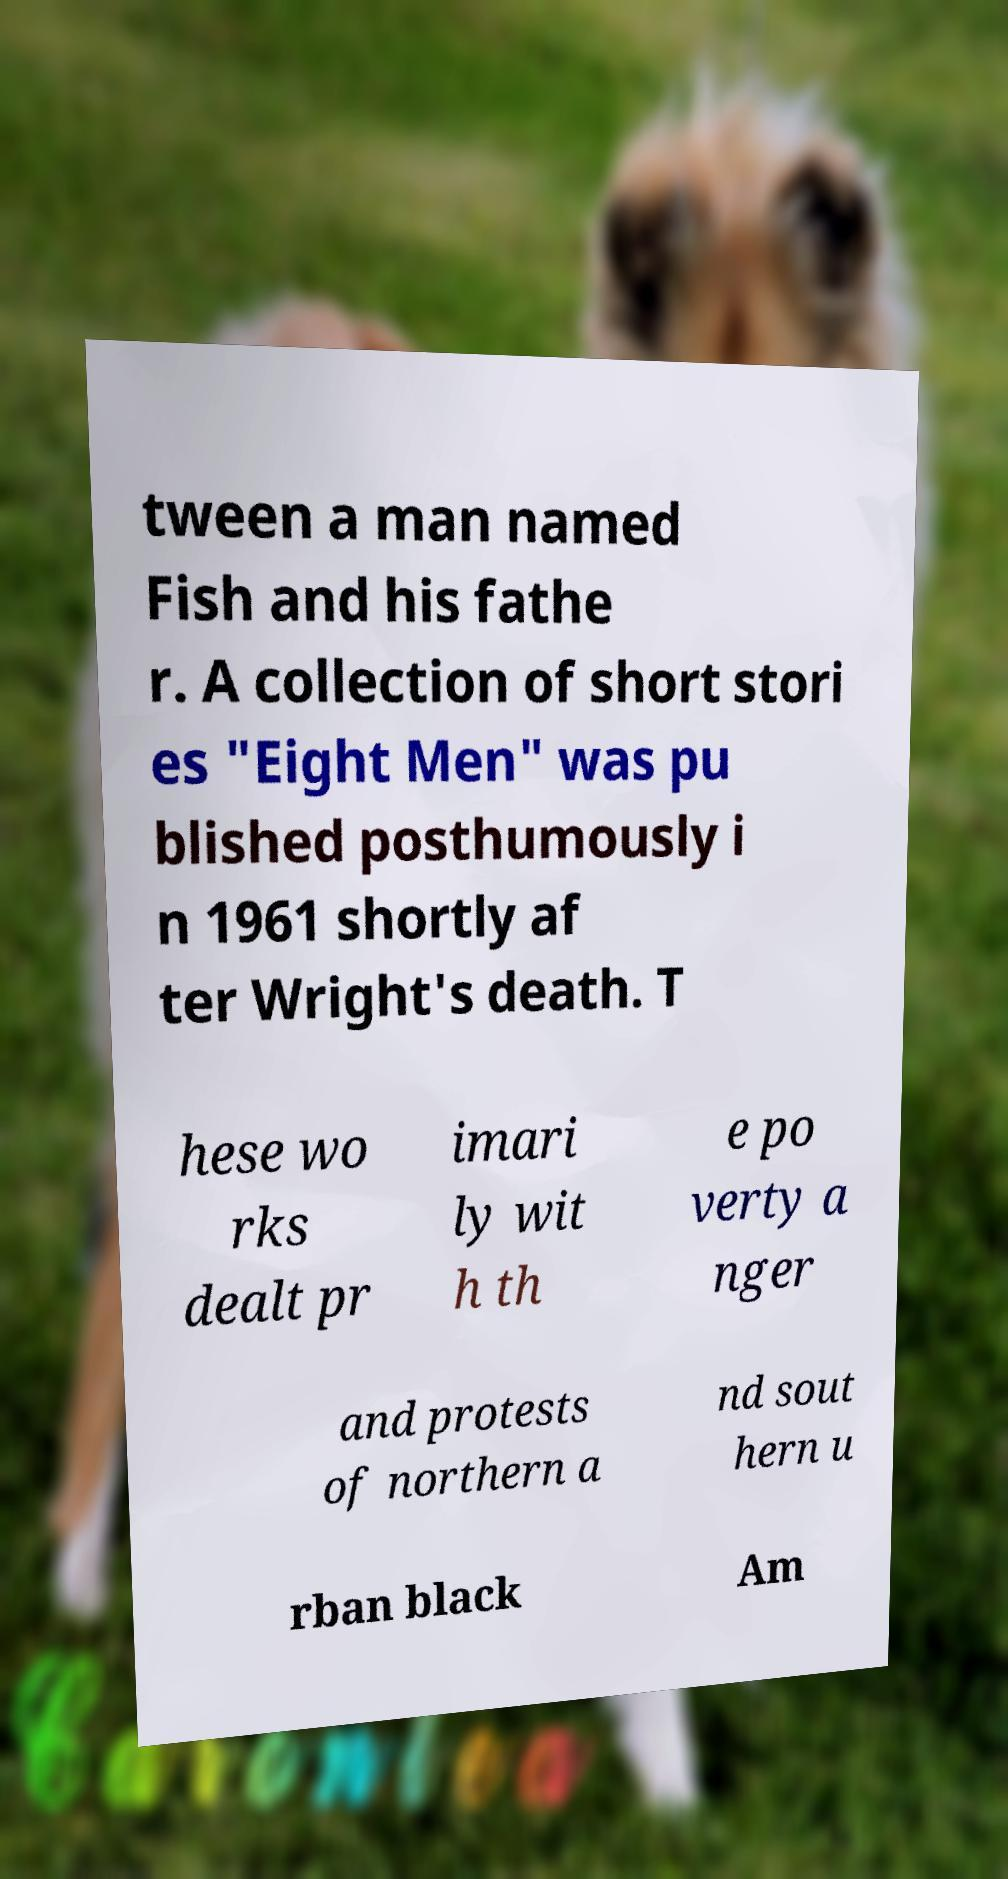Could you extract and type out the text from this image? tween a man named Fish and his fathe r. A collection of short stori es "Eight Men" was pu blished posthumously i n 1961 shortly af ter Wright's death. T hese wo rks dealt pr imari ly wit h th e po verty a nger and protests of northern a nd sout hern u rban black Am 